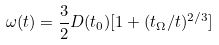<formula> <loc_0><loc_0><loc_500><loc_500>\omega ( t ) = \frac { 3 } { 2 } D ( t _ { 0 } ) [ 1 + ( t _ { \Omega } / t ) ^ { 2 / 3 } ]</formula> 